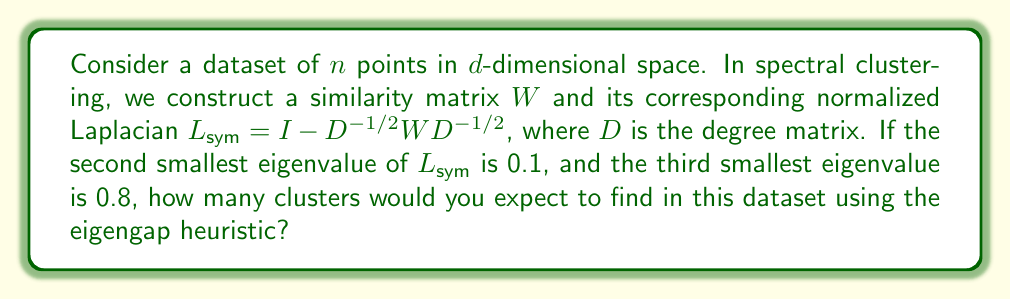Teach me how to tackle this problem. To determine the number of clusters using the eigengap heuristic in spectral clustering, we follow these steps:

1. Recall that the eigengap heuristic suggests choosing the number of clusters $k$ such that the gap between the $k$-th and $(k+1)$-th eigenvalues is large.

2. We are given:
   - Second smallest eigenvalue: $\lambda_2 = 0.1$
   - Third smallest eigenvalue: $\lambda_3 = 0.8$

3. Calculate the eigengap between $\lambda_2$ and $\lambda_3$:
   $$\text{eigengap} = \lambda_3 - \lambda_2 = 0.8 - 0.1 = 0.7$$

4. This large eigengap between the second and third eigenvalues suggests that there are two distinct clusters in the data.

5. In spectral clustering theory, the multiplicity of the eigenvalue 0 corresponds to the number of connected components in the graph. Here, we don't have information about the smallest eigenvalue, but we can assume it's close to 0 (as it should be for a connected graph).

6. The significant jump from 0.1 to 0.8 indicates a natural partition of the data into two clusters.

Therefore, based on the eigengap heuristic, we would expect to find 2 clusters in this dataset.
Answer: 2 clusters 